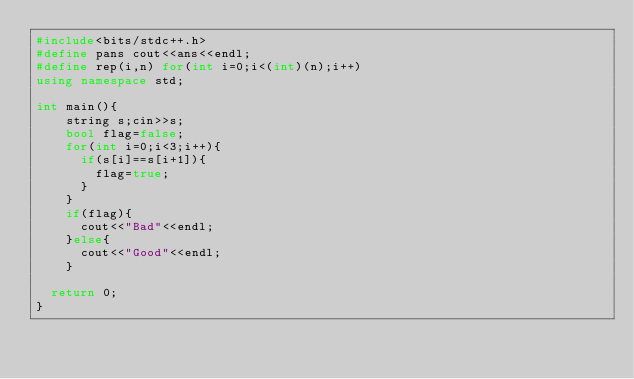<code> <loc_0><loc_0><loc_500><loc_500><_C++_>#include<bits/stdc++.h>
#define pans cout<<ans<<endl;
#define rep(i,n) for(int i=0;i<(int)(n);i++)
using namespace std;

int main(){
  	string s;cin>>s;
    bool flag=false;
  	for(int i=0;i<3;i++){
      if(s[i]==s[i+1]){
        flag=true;
      }
    }
  	if(flag){
      cout<<"Bad"<<endl;
    }else{
      cout<<"Good"<<endl;
    }
  
	return 0;
}</code> 